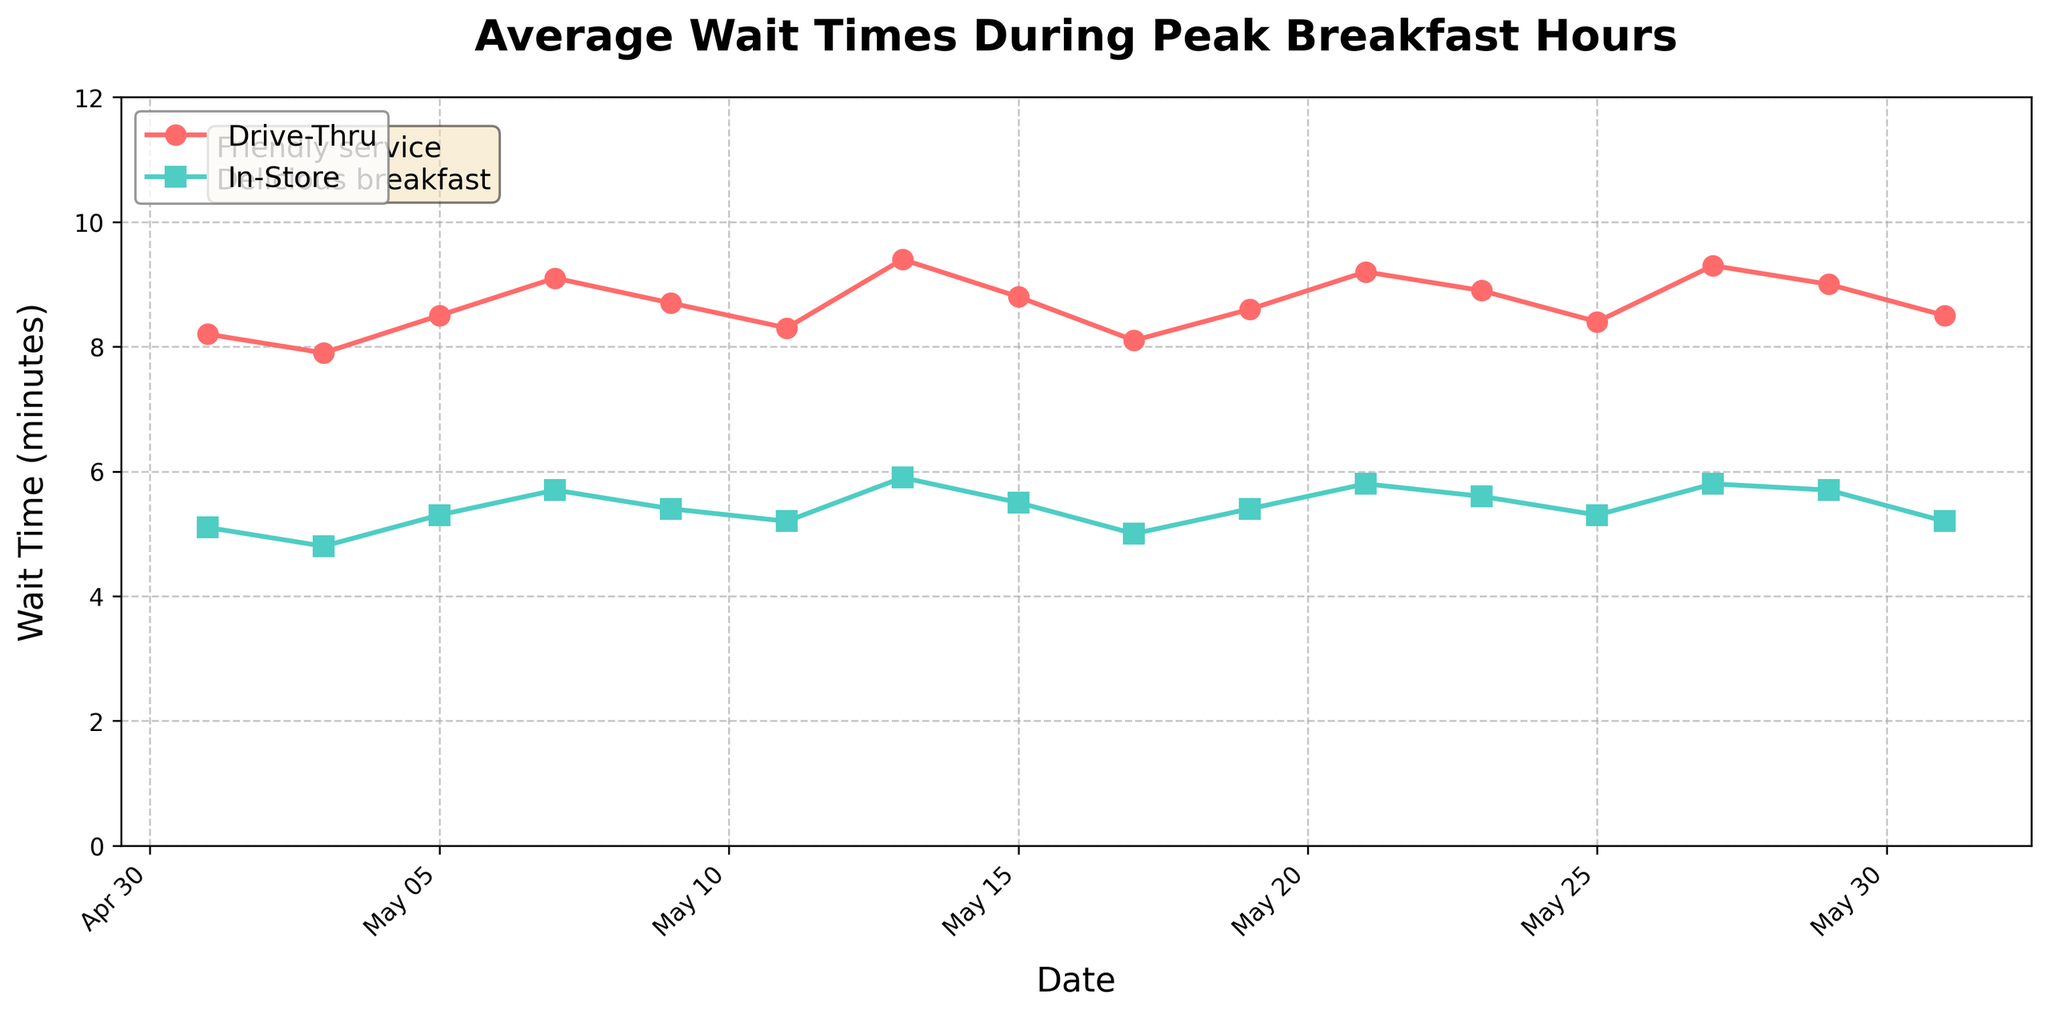Which wait time is, on average, longer: drive-thru or in-store? To find out which wait time is longer on average, calculate the mean wait time for both drive-thru and in-store for the provided dates. Sum all drive-thru times and divide by the number of dates, then do the same for in-store times. The drive-thru average is approximately 8.7 minutes (sum of wait times/16), and the in-store average is approximately 5.4 minutes. Therefore, drive-thru waits longer on average.
Answer: Drive-thru What's the largest difference in wait times between drive-thru and in-store on any single date? Inspect the line chart to identify the dates with the largest gaps between drive-thru and in-store wait times. Compare the differences for each date. For instance, on May 13, the drive-thru wait is 9.4 minutes, and the in-store wait is 5.9 minutes. The difference is 3.5 minutes, which is the largest difference.
Answer: 3.5 minutes On which date did the drive-thru wait time reach its peak? Check within the line plot where the drive-thru wait time achieves the highest value. The peak of the line for drive-thru wait times occurs on May 13 with a wait time of 9.4 minutes.
Answer: May 13 Did either in-store or drive-thru wait times ever decrease over consecutive measurements, and when? Look for points on the line charts where the wait time drops from one date to the next. For the drive-thru, wait times dip from 9.1 minutes on May 7 to 8.7 minutes on May 9, and for in-store, drops from 5.1 minutes on May 1 to 4.8 minutes on May 3.
Answer: Yes; Drive-Thru: May 7 to May 9; In-Store: May 1 to May 3 How did the wait times trend over the month? Observe the overall pattern of both lines throughout the month. Both lines tend to have fluctuations but show no drastic long-term increases or decreases. They fluctuate around a certain range but stay relatively consistent, without any sharp upward or downward trends.
Answer: Fluctuating but stable Is there any date when the drive-thru and in-store wait times were equal? Check the points on the graph where the two lines intersect, showing equal wait times. Looking at the chart, the lines never intersect, indicating the times were not equal at any point.
Answer: No On which date was the in-store wait time closest to the drive-thru wait time? Identify the dates where the gap between the lines representing drive-thru and in-store wait times is narrowest. On May 11, the drive-thru wait time is 8.3 minutes, and the in-store wait time is 5.2 minutes, making the difference 3.1 minutes, which is the smallest among the dates.
Answer: May 11 How does the average wait time for the drive-thru on weekends compare to weekdays? The graph does not explicitly differentiate weekdays from weekends, but you can infer weekends from some dates (e.g., May 7, 13, 21, 27). Calculate the average for these weekend dates and compare it with the average of the remaining weekdays. Weekend drive-thru averages: approximately 8.9 minutes; weekday drive-thru averages: approximately 8.7 minutes.
Answer: Weekends are slightly higher 